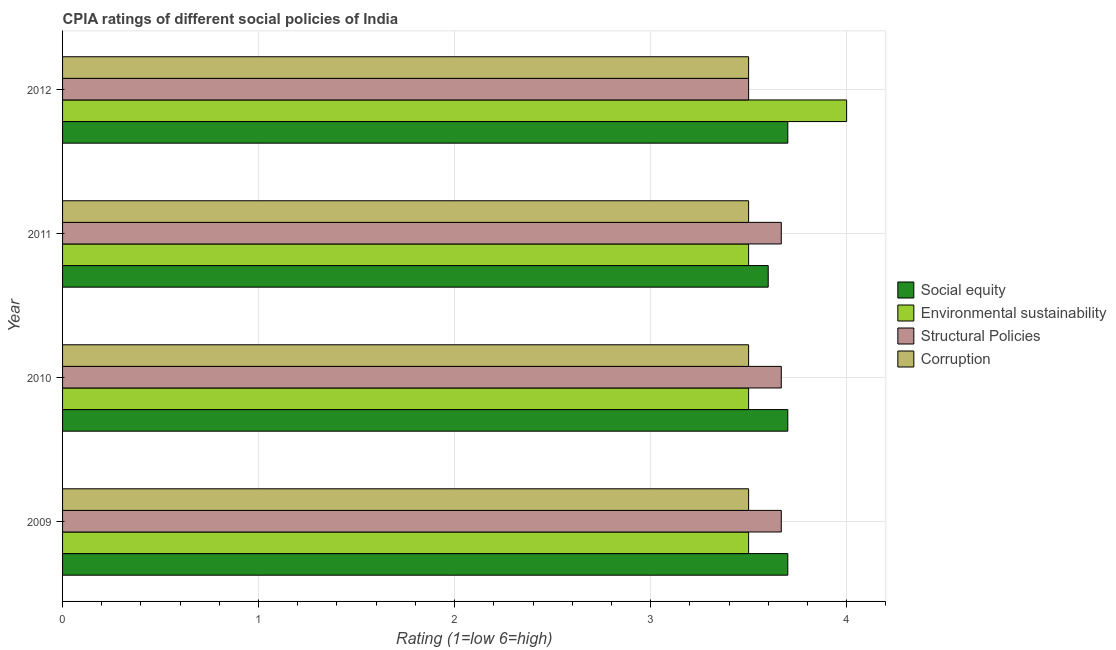How many groups of bars are there?
Ensure brevity in your answer.  4. Are the number of bars per tick equal to the number of legend labels?
Your answer should be compact. Yes. How many bars are there on the 4th tick from the bottom?
Offer a terse response. 4. What is the label of the 1st group of bars from the top?
Provide a short and direct response. 2012. In how many cases, is the number of bars for a given year not equal to the number of legend labels?
Your answer should be compact. 0. What is the cpia rating of structural policies in 2011?
Your answer should be compact. 3.67. Across all years, what is the maximum cpia rating of structural policies?
Make the answer very short. 3.67. In which year was the cpia rating of social equity minimum?
Make the answer very short. 2011. What is the total cpia rating of structural policies in the graph?
Your answer should be very brief. 14.5. What is the difference between the cpia rating of social equity in 2010 and that in 2011?
Your response must be concise. 0.1. What is the difference between the cpia rating of corruption in 2010 and the cpia rating of social equity in 2012?
Your answer should be compact. -0.2. What is the average cpia rating of social equity per year?
Provide a succinct answer. 3.67. In the year 2009, what is the difference between the cpia rating of environmental sustainability and cpia rating of structural policies?
Make the answer very short. -0.17. In how many years, is the cpia rating of structural policies greater than 2.2 ?
Your answer should be very brief. 4. What is the ratio of the cpia rating of structural policies in 2010 to that in 2012?
Your answer should be compact. 1.05. Is the cpia rating of environmental sustainability in 2010 less than that in 2012?
Give a very brief answer. Yes. What is the difference between the highest and the second highest cpia rating of structural policies?
Your response must be concise. 0. What is the difference between the highest and the lowest cpia rating of social equity?
Provide a succinct answer. 0.1. In how many years, is the cpia rating of social equity greater than the average cpia rating of social equity taken over all years?
Provide a succinct answer. 3. Is the sum of the cpia rating of structural policies in 2009 and 2012 greater than the maximum cpia rating of environmental sustainability across all years?
Your response must be concise. Yes. What does the 3rd bar from the top in 2009 represents?
Provide a short and direct response. Environmental sustainability. What does the 4th bar from the bottom in 2011 represents?
Your response must be concise. Corruption. Is it the case that in every year, the sum of the cpia rating of social equity and cpia rating of environmental sustainability is greater than the cpia rating of structural policies?
Keep it short and to the point. Yes. How many bars are there?
Your answer should be compact. 16. How many years are there in the graph?
Your answer should be compact. 4. What is the difference between two consecutive major ticks on the X-axis?
Provide a succinct answer. 1. Does the graph contain any zero values?
Offer a very short reply. No. How many legend labels are there?
Offer a very short reply. 4. What is the title of the graph?
Keep it short and to the point. CPIA ratings of different social policies of India. Does "Offering training" appear as one of the legend labels in the graph?
Keep it short and to the point. No. What is the Rating (1=low 6=high) in Social equity in 2009?
Offer a terse response. 3.7. What is the Rating (1=low 6=high) of Environmental sustainability in 2009?
Ensure brevity in your answer.  3.5. What is the Rating (1=low 6=high) of Structural Policies in 2009?
Provide a short and direct response. 3.67. What is the Rating (1=low 6=high) in Corruption in 2009?
Ensure brevity in your answer.  3.5. What is the Rating (1=low 6=high) of Social equity in 2010?
Provide a short and direct response. 3.7. What is the Rating (1=low 6=high) of Structural Policies in 2010?
Offer a terse response. 3.67. What is the Rating (1=low 6=high) of Corruption in 2010?
Your answer should be very brief. 3.5. What is the Rating (1=low 6=high) of Structural Policies in 2011?
Keep it short and to the point. 3.67. What is the Rating (1=low 6=high) of Corruption in 2011?
Offer a terse response. 3.5. What is the Rating (1=low 6=high) in Social equity in 2012?
Your response must be concise. 3.7. What is the Rating (1=low 6=high) of Structural Policies in 2012?
Keep it short and to the point. 3.5. What is the Rating (1=low 6=high) of Corruption in 2012?
Provide a short and direct response. 3.5. Across all years, what is the maximum Rating (1=low 6=high) in Social equity?
Provide a succinct answer. 3.7. Across all years, what is the maximum Rating (1=low 6=high) of Environmental sustainability?
Offer a terse response. 4. Across all years, what is the maximum Rating (1=low 6=high) of Structural Policies?
Provide a succinct answer. 3.67. What is the total Rating (1=low 6=high) in Environmental sustainability in the graph?
Provide a short and direct response. 14.5. What is the total Rating (1=low 6=high) of Structural Policies in the graph?
Provide a succinct answer. 14.5. What is the difference between the Rating (1=low 6=high) of Social equity in 2009 and that in 2010?
Give a very brief answer. 0. What is the difference between the Rating (1=low 6=high) in Environmental sustainability in 2009 and that in 2010?
Offer a terse response. 0. What is the difference between the Rating (1=low 6=high) of Structural Policies in 2009 and that in 2010?
Ensure brevity in your answer.  0. What is the difference between the Rating (1=low 6=high) in Social equity in 2009 and that in 2011?
Provide a short and direct response. 0.1. What is the difference between the Rating (1=low 6=high) in Corruption in 2009 and that in 2011?
Offer a very short reply. 0. What is the difference between the Rating (1=low 6=high) of Environmental sustainability in 2009 and that in 2012?
Your answer should be compact. -0.5. What is the difference between the Rating (1=low 6=high) of Corruption in 2009 and that in 2012?
Offer a very short reply. 0. What is the difference between the Rating (1=low 6=high) in Social equity in 2010 and that in 2011?
Give a very brief answer. 0.1. What is the difference between the Rating (1=low 6=high) in Social equity in 2010 and that in 2012?
Your answer should be compact. 0. What is the difference between the Rating (1=low 6=high) of Environmental sustainability in 2010 and that in 2012?
Your answer should be compact. -0.5. What is the difference between the Rating (1=low 6=high) in Structural Policies in 2010 and that in 2012?
Give a very brief answer. 0.17. What is the difference between the Rating (1=low 6=high) in Corruption in 2010 and that in 2012?
Your answer should be compact. 0. What is the difference between the Rating (1=low 6=high) in Environmental sustainability in 2011 and that in 2012?
Your response must be concise. -0.5. What is the difference between the Rating (1=low 6=high) in Structural Policies in 2011 and that in 2012?
Your answer should be very brief. 0.17. What is the difference between the Rating (1=low 6=high) in Corruption in 2011 and that in 2012?
Your answer should be very brief. 0. What is the difference between the Rating (1=low 6=high) of Social equity in 2009 and the Rating (1=low 6=high) of Structural Policies in 2010?
Ensure brevity in your answer.  0.03. What is the difference between the Rating (1=low 6=high) in Social equity in 2009 and the Rating (1=low 6=high) in Corruption in 2010?
Your response must be concise. 0.2. What is the difference between the Rating (1=low 6=high) in Environmental sustainability in 2009 and the Rating (1=low 6=high) in Corruption in 2010?
Your answer should be compact. 0. What is the difference between the Rating (1=low 6=high) of Social equity in 2009 and the Rating (1=low 6=high) of Environmental sustainability in 2011?
Make the answer very short. 0.2. What is the difference between the Rating (1=low 6=high) of Social equity in 2009 and the Rating (1=low 6=high) of Environmental sustainability in 2012?
Offer a terse response. -0.3. What is the difference between the Rating (1=low 6=high) in Social equity in 2009 and the Rating (1=low 6=high) in Corruption in 2012?
Offer a very short reply. 0.2. What is the difference between the Rating (1=low 6=high) in Environmental sustainability in 2009 and the Rating (1=low 6=high) in Structural Policies in 2012?
Your answer should be compact. 0. What is the difference between the Rating (1=low 6=high) in Environmental sustainability in 2009 and the Rating (1=low 6=high) in Corruption in 2012?
Your response must be concise. 0. What is the difference between the Rating (1=low 6=high) of Social equity in 2010 and the Rating (1=low 6=high) of Environmental sustainability in 2011?
Provide a succinct answer. 0.2. What is the difference between the Rating (1=low 6=high) of Social equity in 2010 and the Rating (1=low 6=high) of Corruption in 2011?
Offer a very short reply. 0.2. What is the difference between the Rating (1=low 6=high) in Environmental sustainability in 2010 and the Rating (1=low 6=high) in Structural Policies in 2011?
Offer a very short reply. -0.17. What is the difference between the Rating (1=low 6=high) of Social equity in 2010 and the Rating (1=low 6=high) of Corruption in 2012?
Provide a succinct answer. 0.2. What is the difference between the Rating (1=low 6=high) in Environmental sustainability in 2011 and the Rating (1=low 6=high) in Corruption in 2012?
Offer a terse response. 0. What is the average Rating (1=low 6=high) of Social equity per year?
Keep it short and to the point. 3.67. What is the average Rating (1=low 6=high) in Environmental sustainability per year?
Offer a terse response. 3.62. What is the average Rating (1=low 6=high) in Structural Policies per year?
Your answer should be very brief. 3.62. In the year 2009, what is the difference between the Rating (1=low 6=high) of Social equity and Rating (1=low 6=high) of Corruption?
Keep it short and to the point. 0.2. In the year 2009, what is the difference between the Rating (1=low 6=high) in Environmental sustainability and Rating (1=low 6=high) in Structural Policies?
Make the answer very short. -0.17. In the year 2009, what is the difference between the Rating (1=low 6=high) of Environmental sustainability and Rating (1=low 6=high) of Corruption?
Provide a short and direct response. 0. In the year 2009, what is the difference between the Rating (1=low 6=high) of Structural Policies and Rating (1=low 6=high) of Corruption?
Provide a short and direct response. 0.17. In the year 2010, what is the difference between the Rating (1=low 6=high) in Social equity and Rating (1=low 6=high) in Environmental sustainability?
Make the answer very short. 0.2. In the year 2010, what is the difference between the Rating (1=low 6=high) in Social equity and Rating (1=low 6=high) in Corruption?
Give a very brief answer. 0.2. In the year 2010, what is the difference between the Rating (1=low 6=high) in Environmental sustainability and Rating (1=low 6=high) in Structural Policies?
Make the answer very short. -0.17. In the year 2010, what is the difference between the Rating (1=low 6=high) in Structural Policies and Rating (1=low 6=high) in Corruption?
Offer a very short reply. 0.17. In the year 2011, what is the difference between the Rating (1=low 6=high) of Social equity and Rating (1=low 6=high) of Structural Policies?
Your answer should be compact. -0.07. In the year 2011, what is the difference between the Rating (1=low 6=high) in Environmental sustainability and Rating (1=low 6=high) in Corruption?
Provide a succinct answer. 0. In the year 2011, what is the difference between the Rating (1=low 6=high) in Structural Policies and Rating (1=low 6=high) in Corruption?
Give a very brief answer. 0.17. In the year 2012, what is the difference between the Rating (1=low 6=high) in Social equity and Rating (1=low 6=high) in Environmental sustainability?
Give a very brief answer. -0.3. In the year 2012, what is the difference between the Rating (1=low 6=high) of Social equity and Rating (1=low 6=high) of Corruption?
Your answer should be very brief. 0.2. In the year 2012, what is the difference between the Rating (1=low 6=high) in Environmental sustainability and Rating (1=low 6=high) in Corruption?
Make the answer very short. 0.5. What is the ratio of the Rating (1=low 6=high) in Corruption in 2009 to that in 2010?
Make the answer very short. 1. What is the ratio of the Rating (1=low 6=high) in Social equity in 2009 to that in 2011?
Provide a succinct answer. 1.03. What is the ratio of the Rating (1=low 6=high) of Environmental sustainability in 2009 to that in 2011?
Keep it short and to the point. 1. What is the ratio of the Rating (1=low 6=high) of Social equity in 2009 to that in 2012?
Provide a succinct answer. 1. What is the ratio of the Rating (1=low 6=high) in Environmental sustainability in 2009 to that in 2012?
Make the answer very short. 0.88. What is the ratio of the Rating (1=low 6=high) in Structural Policies in 2009 to that in 2012?
Make the answer very short. 1.05. What is the ratio of the Rating (1=low 6=high) in Corruption in 2009 to that in 2012?
Provide a short and direct response. 1. What is the ratio of the Rating (1=low 6=high) in Social equity in 2010 to that in 2011?
Provide a short and direct response. 1.03. What is the ratio of the Rating (1=low 6=high) of Environmental sustainability in 2010 to that in 2011?
Make the answer very short. 1. What is the ratio of the Rating (1=low 6=high) in Structural Policies in 2010 to that in 2011?
Ensure brevity in your answer.  1. What is the ratio of the Rating (1=low 6=high) of Corruption in 2010 to that in 2011?
Provide a succinct answer. 1. What is the ratio of the Rating (1=low 6=high) in Social equity in 2010 to that in 2012?
Keep it short and to the point. 1. What is the ratio of the Rating (1=low 6=high) in Structural Policies in 2010 to that in 2012?
Your answer should be very brief. 1.05. What is the ratio of the Rating (1=low 6=high) of Structural Policies in 2011 to that in 2012?
Make the answer very short. 1.05. What is the difference between the highest and the second highest Rating (1=low 6=high) of Social equity?
Keep it short and to the point. 0. What is the difference between the highest and the second highest Rating (1=low 6=high) of Environmental sustainability?
Give a very brief answer. 0.5. What is the difference between the highest and the second highest Rating (1=low 6=high) of Structural Policies?
Make the answer very short. 0. What is the difference between the highest and the lowest Rating (1=low 6=high) of Social equity?
Keep it short and to the point. 0.1. 